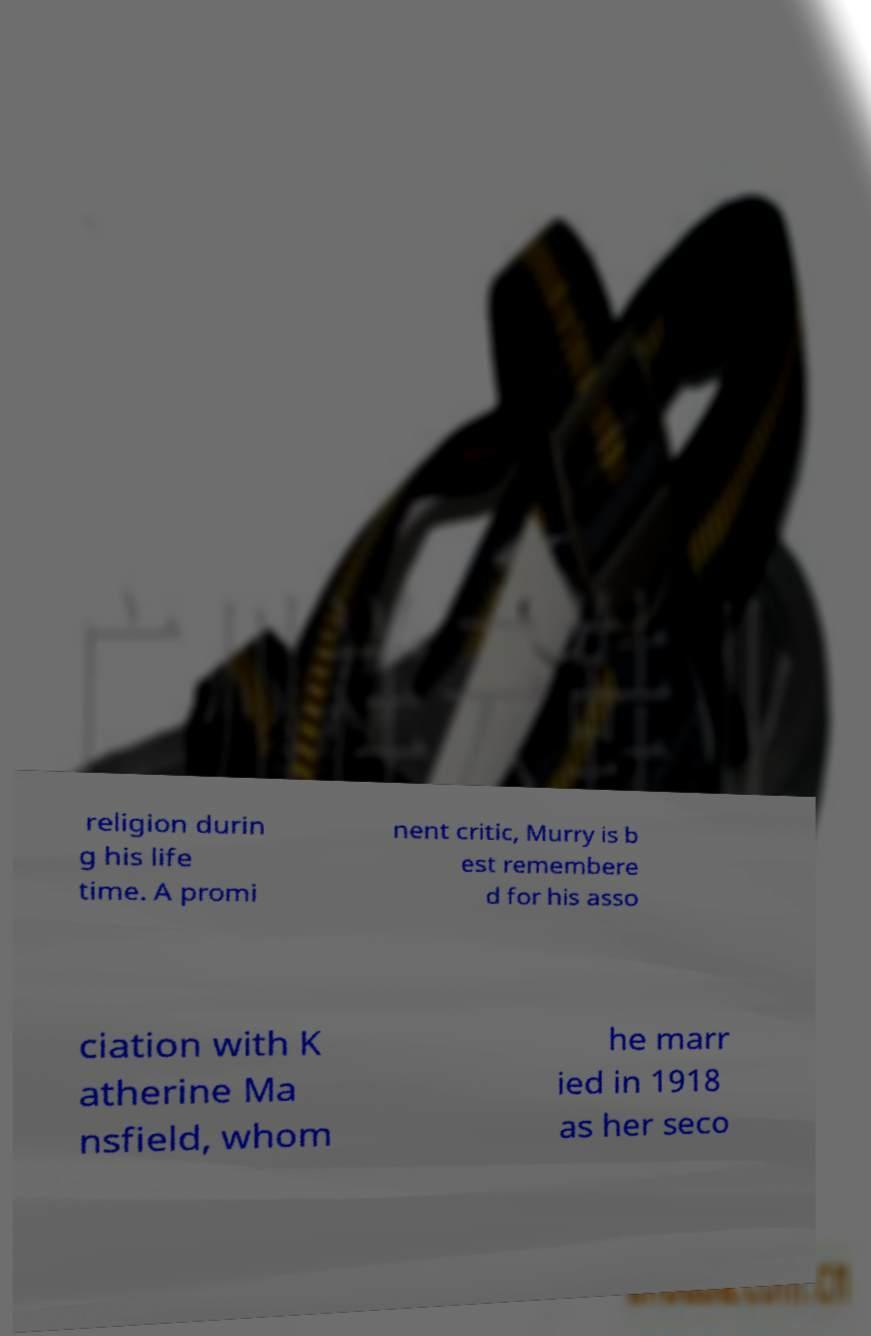Can you read and provide the text displayed in the image?This photo seems to have some interesting text. Can you extract and type it out for me? religion durin g his life time. A promi nent critic, Murry is b est remembere d for his asso ciation with K atherine Ma nsfield, whom he marr ied in 1918 as her seco 